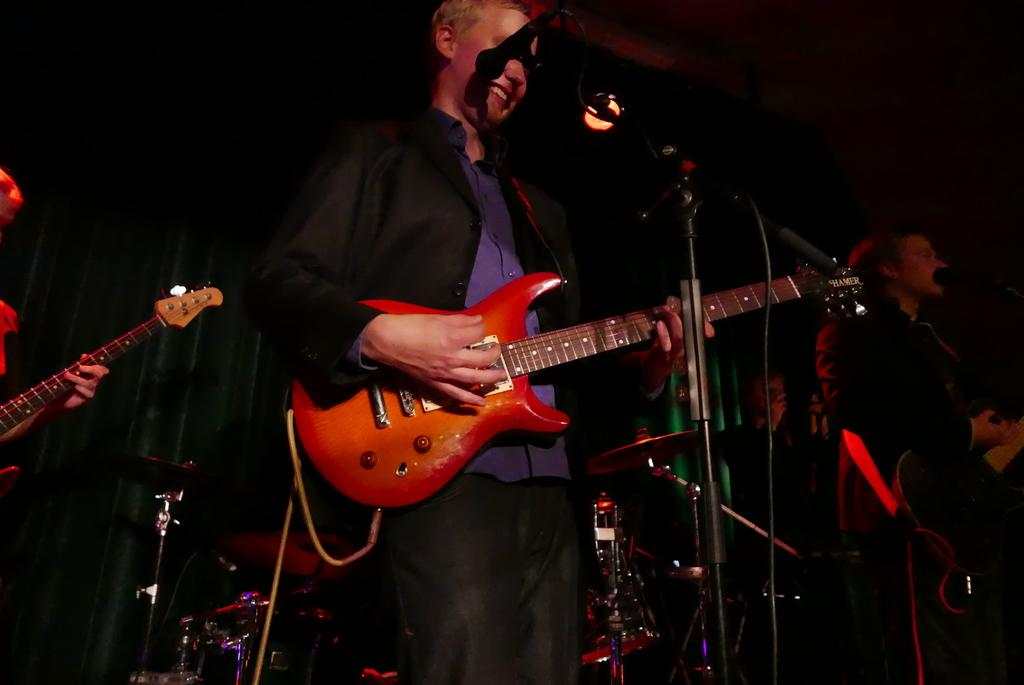What is the man in the image doing? The man is standing and holding a guitar. What object is in front of the man? There is a microphone in front of the man. What can be seen in the background of the image? There are musical instruments and people standing in the background of the image. What type of class is being taught in the image? There is no class present in the image; it features a man holding a guitar and a microphone in front of him. What is the man doing with his thumb in the image? The man's thumb is not visible or mentioned in the image, so it cannot be determined what he is doing with it. 